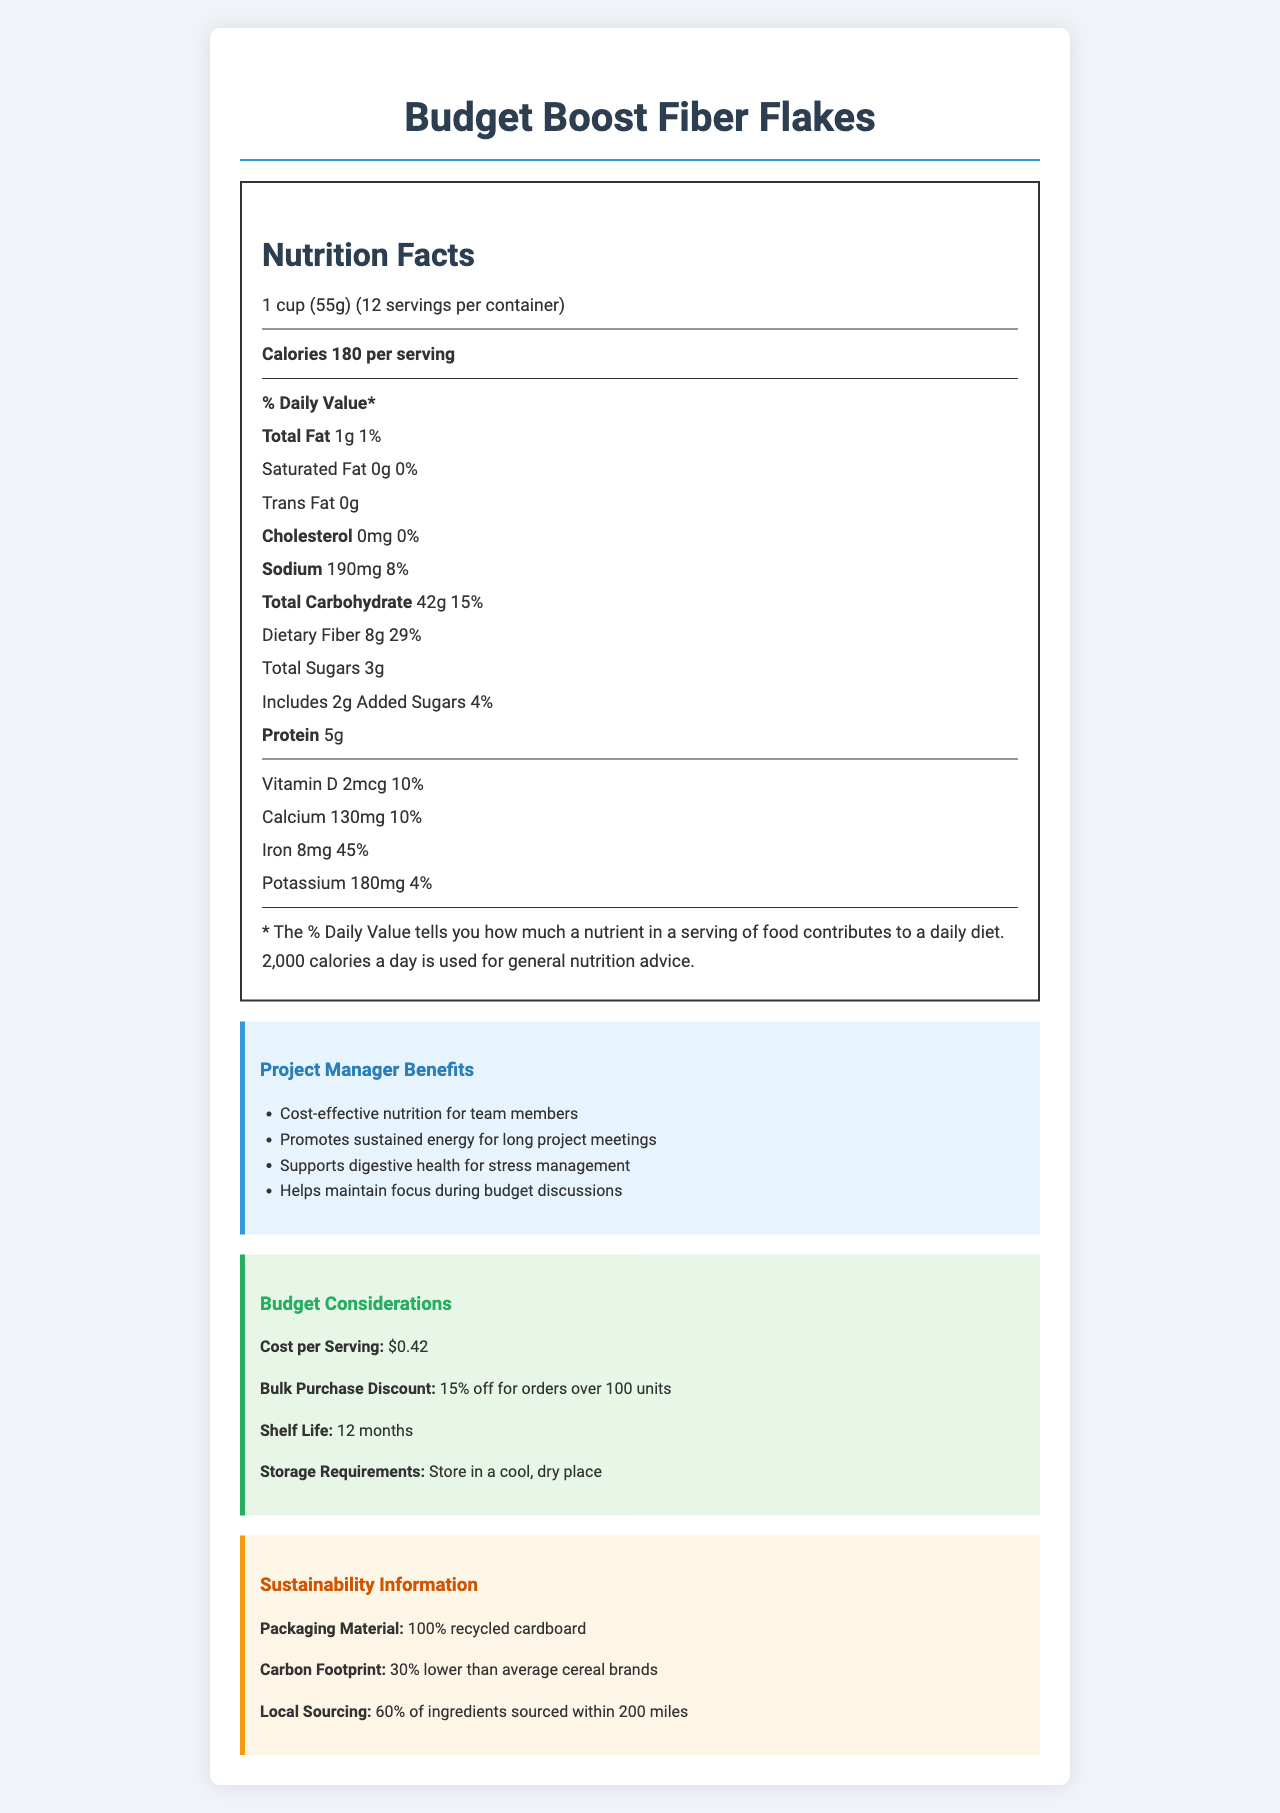what is the serving size of Budget Boost Fiber Flakes? The serving size is listed as "1 cup (55g)" in the document.
Answer: 1 cup (55g) how many servings are there per container? The document specifies that there are "12 servings per container".
Answer: 12 how many calories are in one serving? The "Calories per serving" section indicates that there are 180 calories per serving.
Answer: 180 what is the total fat content per serving of this cereal? The document states that the total fat per serving is "1g".
Answer: 1g how much dietary fiber does one serving contain? The dietary fiber content is "8g" per serving, as given in the nutrition facts.
Answer: 8g which vitamin is present in the highest percentage of daily value per serving? A. Vitamin D B. Calcium C. Iron D. Potassium The document shows that iron has a daily value of 45%, which is the highest among the listed vitamins and minerals.
Answer: C. Iron what is the cost per serving of Budget Boost Fiber Flakes? A. $0.35 B. $0.40 C. $0.42 D. $0.50 The budget considerations section states that the cost per serving is "$0.42".
Answer: C. $0.42 are there any allergens in Budget Boost Fiber Flakes? The document mentions that the product "Contains wheat" and "May contain traces of nuts".
Answer: Yes what is the shelf life of Budget Boost Fiber Flakes? The shelf life of the cereal is given as "12 months" under budget considerations.
Answer: 12 months how much sodium is in one serving? According to the nutrition facts, one serving contains "190mg" of sodium.
Answer: 190mg is Budget Boost Fiber Flakes a high-fiber cereal? The health claims section lists "High in fiber" as one of the benefits.
Answer: Yes for effective budget management, what bulk purchase discount is offered? The document states that there is a "15% off for orders over 100 units" bulk purchase discount.
Answer: 15% off for orders over 100 units what are the suggested storage requirements for Budget Boost Fiber Flakes? The document provides the storage requirements as "Store in a cool, dry place".
Answer: Store in a cool, dry place summarize the main benefits of Budget Boost Fiber Flakes for a project manager. The document highlights that Budget Boost Fiber Flakes are cost-effective, promote sustained energy, support digestive health, and help maintain focus during budget discussions.
Answer: Cost-effective nutrition, promotes sustained energy, supports digestive health, helps maintain focus what percent of daily value does the total carbohydrate in one serving represent? The total carbohydrate per serving represents "15%" of the daily value.
Answer: 15% is the carbon footprint of this cereal higher or lower than the average cereal brand? The document states that Budget Boost Fiber Flakes has a "30% lower" carbon footprint than average cereal brands.
Answer: Lower where are most of the ingredients for Budget Boost Fiber Flakes sourced from? The sustainability section notes that "60% of ingredients" are sourced within 200 miles.
Answer: Within 200 miles what is the percentage of potassium’s daily value in one serving? The document shows that potassium has a daily value percentage of "4%".
Answer: 4% how can Budget Boost Fiber Flakes help in managing long project meetings? The project manager benefits section mentions that the cereal "Promotes sustained energy for long project meetings".
Answer: Promotes sustained energy what is the percentage of added sugars in one serving? The document lists that added sugars represent "4%" of the daily value per serving.
Answer: 4% which ingredient is not present in Budget Boost Fiber Flakes? A. Whole grain wheat B. Corn syrup C. Barley malt extract D. Rice The list of ingredients includes whole grain wheat, barley malt extract, and rice, but not corn syrup.
Answer: B. Corn syrup cannot be answered: what is the cereal's flavor? The document does not provide any details regarding the flavor of the cereal.
Answer: Not enough information 